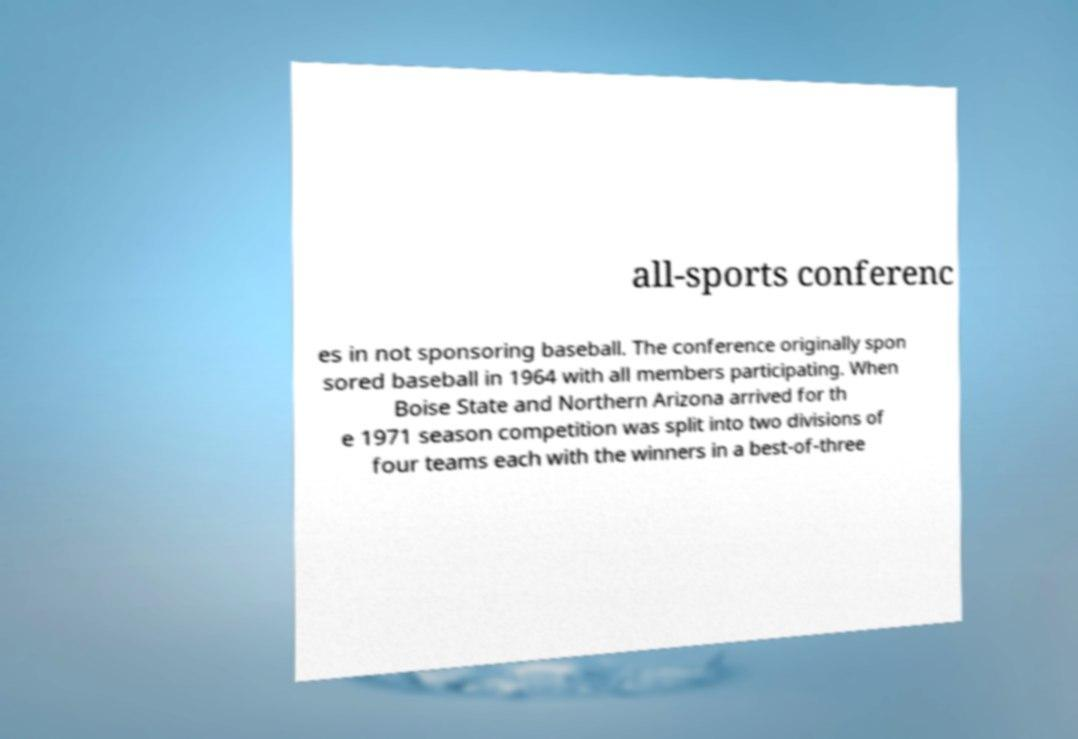Can you read and provide the text displayed in the image?This photo seems to have some interesting text. Can you extract and type it out for me? all-sports conferenc es in not sponsoring baseball. The conference originally spon sored baseball in 1964 with all members participating. When Boise State and Northern Arizona arrived for th e 1971 season competition was split into two divisions of four teams each with the winners in a best-of-three 